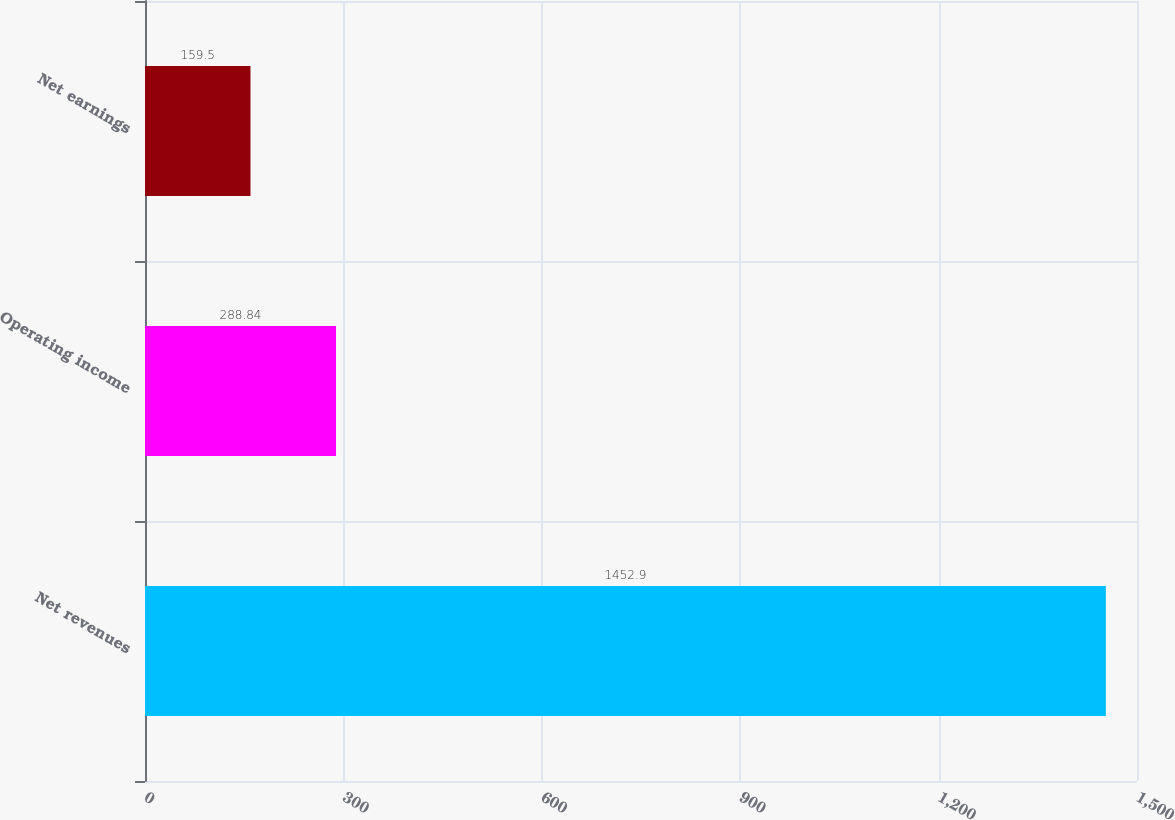Convert chart. <chart><loc_0><loc_0><loc_500><loc_500><bar_chart><fcel>Net revenues<fcel>Operating income<fcel>Net earnings<nl><fcel>1452.9<fcel>288.84<fcel>159.5<nl></chart> 